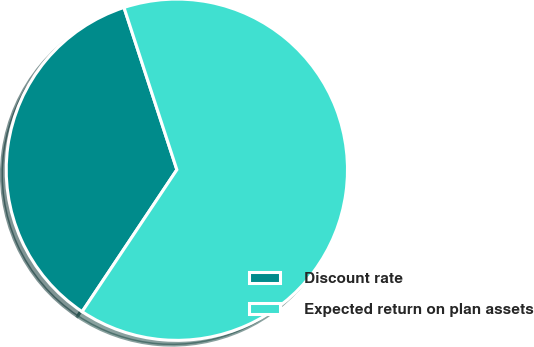Convert chart to OTSL. <chart><loc_0><loc_0><loc_500><loc_500><pie_chart><fcel>Discount rate<fcel>Expected return on plan assets<nl><fcel>35.62%<fcel>64.38%<nl></chart> 